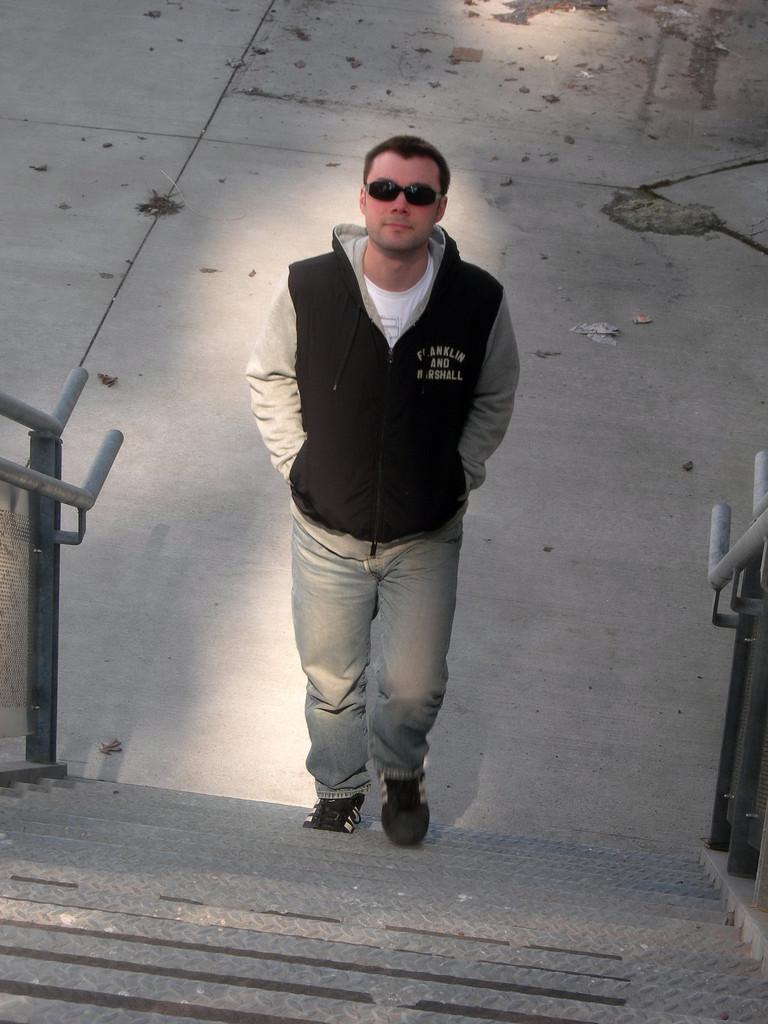Who is present in the image? There is a man in the image. What is the man doing in the image? The man is walking on stairs. What safety feature is present on the stairs? There is a railing on either side of the stairs. What can be seen in the background of the image? There is a pavement in the background of the image. Can you see the queen waving from the island in the image? There is no queen or island present in the image; it features a man walking on stairs with railings and a pavement in the background. 